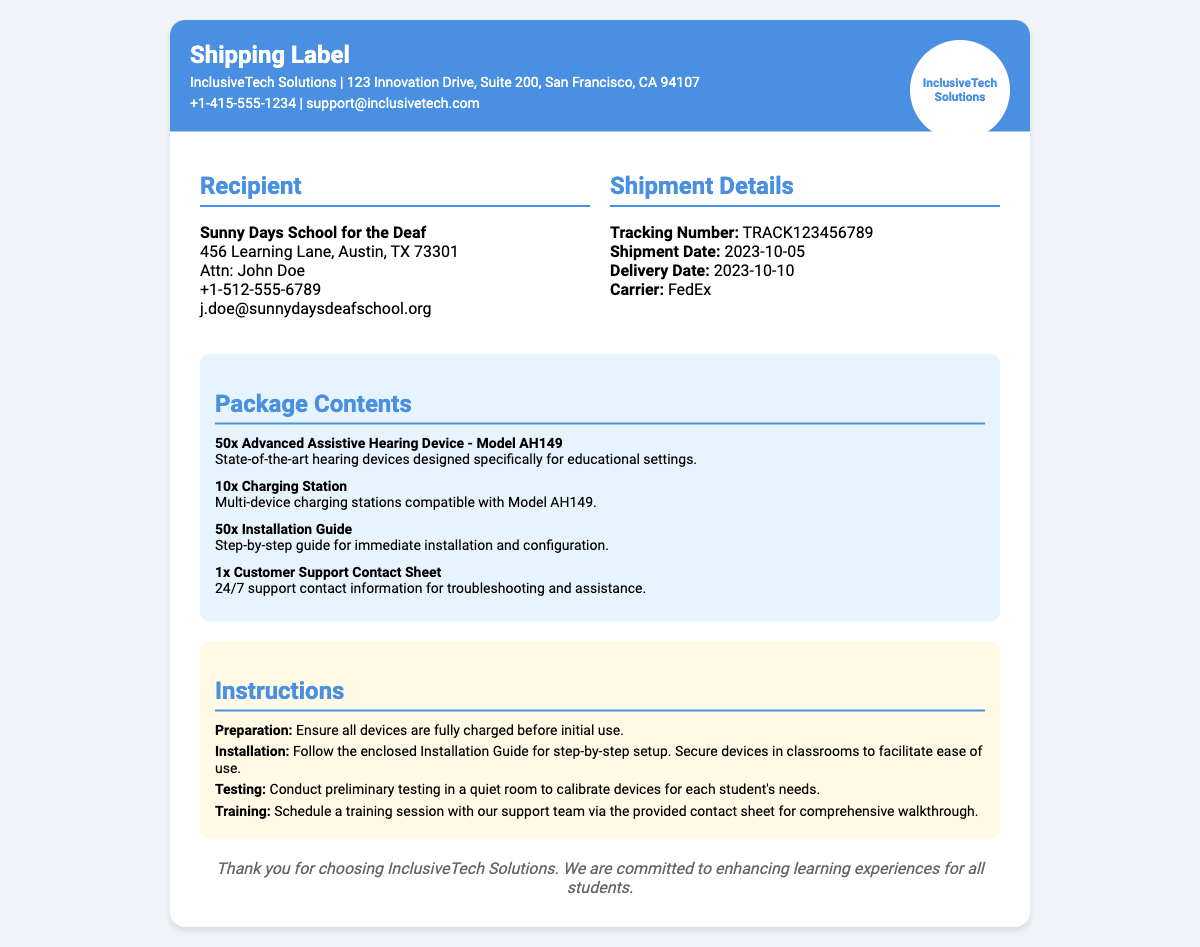What is the name of the recipient school? The document mentions the recipient as "Sunny Days School for the Deaf."
Answer: Sunny Days School for the Deaf What is the tracking number for this shipment? The shipping label states the tracking number prominently as "TRACK123456789."
Answer: TRACK123456789 How many Advanced Assistive Hearing Devices are included in the package? The contents section indicates "50x Advanced Assistive Hearing Device - Model AH149."
Answer: 50 What is the shipment date? According to the shipment details, the shipment date is "2023-10-05."
Answer: 2023-10-05 What do the installation guidelines suggest about device preparation? The installation guidelines specify that devices should be "fully charged before initial use."
Answer: fully charged How many charging stations are included in the shipment? The package contents state there are "10x Charging Station."
Answer: 10 What should be done during preliminary testing? The instructions describe conducting "preliminary testing in a quiet room."
Answer: preliminary testing in a quiet room Which organization provides customer support for the devices? The logo on the shipping label indicates the customer support is provided by "InclusiveTech Solutions."
Answer: InclusiveTech Solutions What is the delivery date for this shipment? The document states the delivery date as "2023-10-10."
Answer: 2023-10-10 